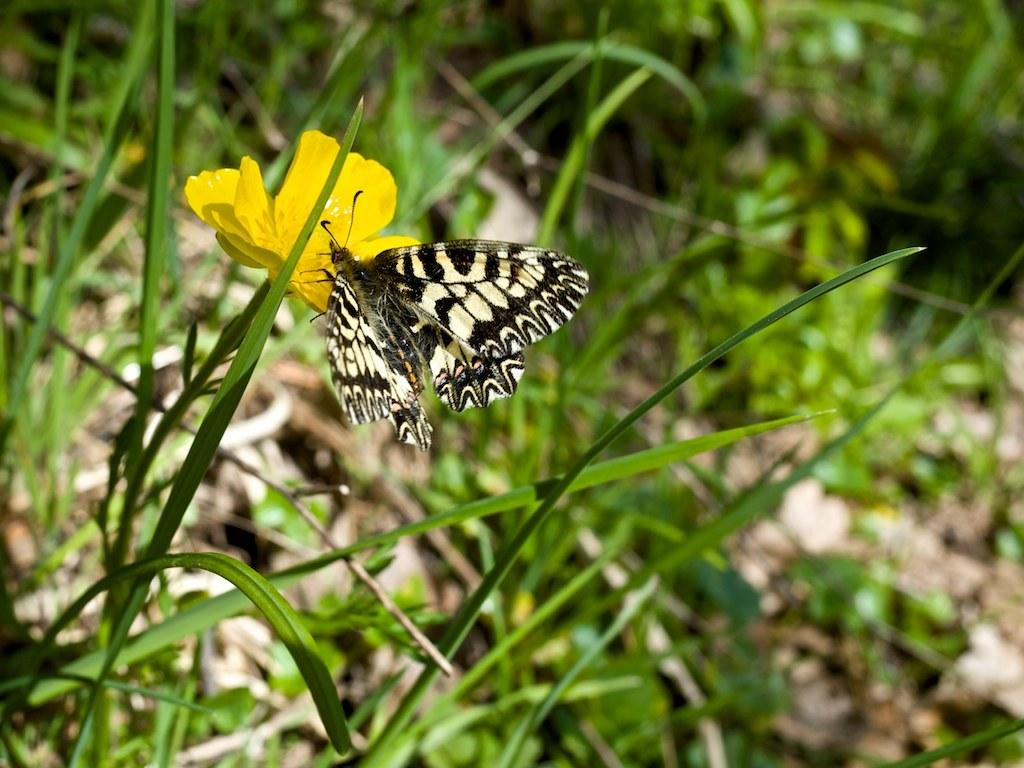What is the main subject in the foreground of the image? There is a butterfly in the foreground of the image. Can you describe the color pattern of the butterfly? The butterfly has a cream and black color pattern. What is the butterfly sitting on in the image? The butterfly is on a yellow flower. What can be seen in the background of the image? There is grass and plants visible in the background of the image. How much respect does the butterfly show for the money in the image? There is no money present in the image, so the butterfly cannot show any respect for it. 